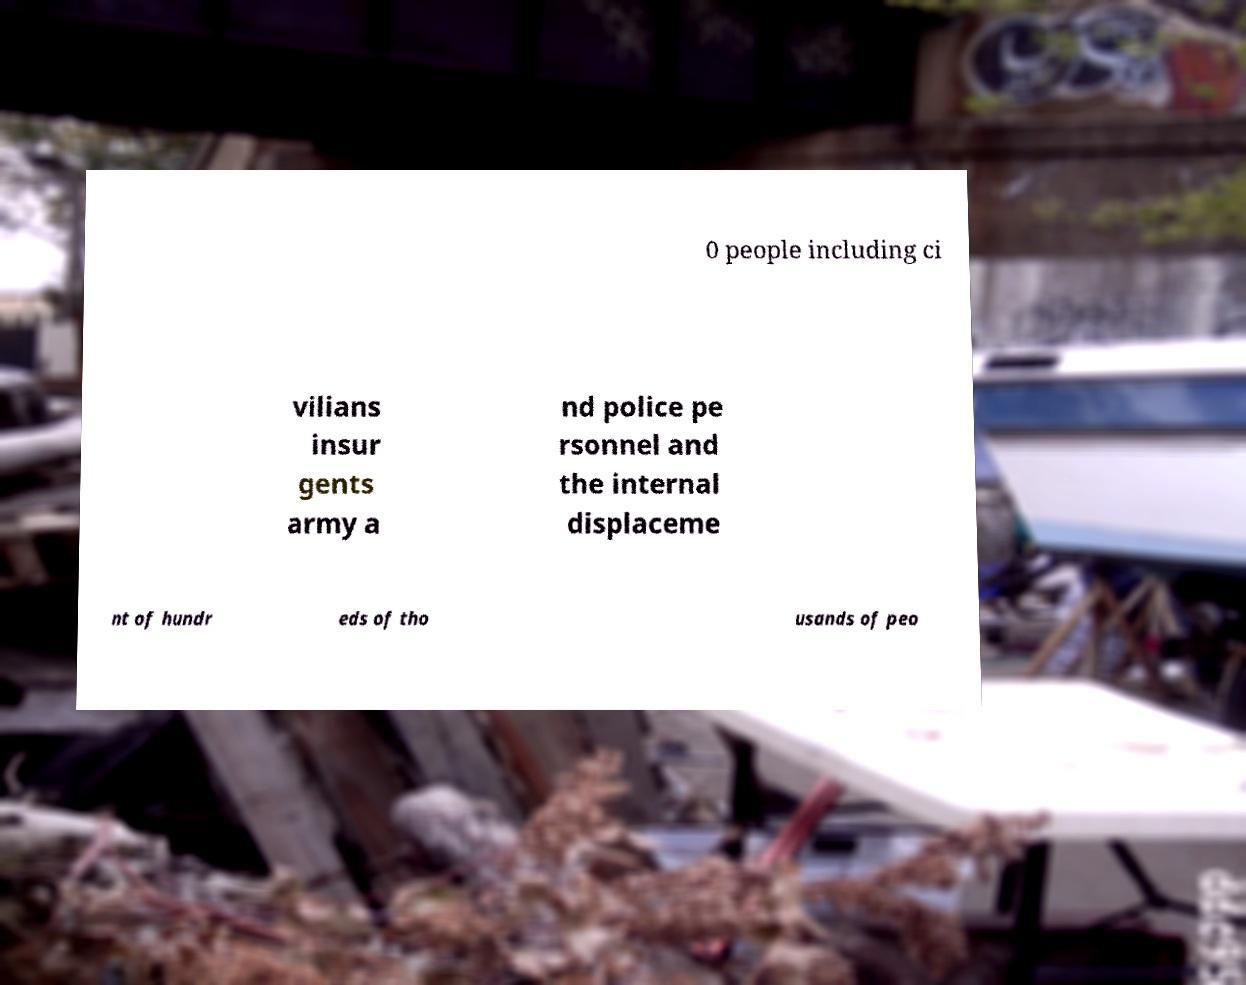For documentation purposes, I need the text within this image transcribed. Could you provide that? 0 people including ci vilians insur gents army a nd police pe rsonnel and the internal displaceme nt of hundr eds of tho usands of peo 